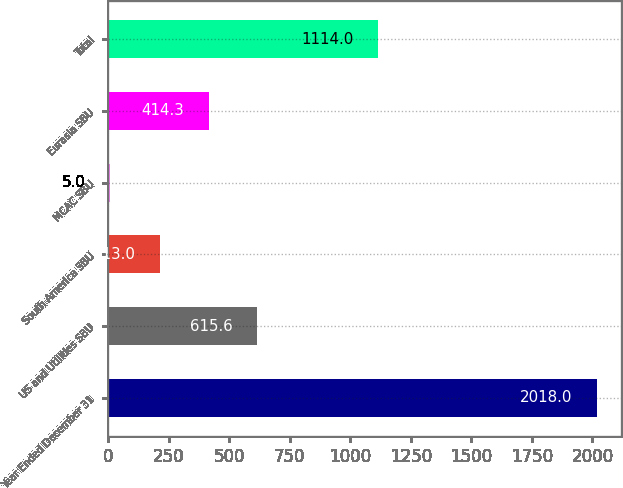Convert chart to OTSL. <chart><loc_0><loc_0><loc_500><loc_500><bar_chart><fcel>Year Ended December 31<fcel>US and Utilities SBU<fcel>South America SBU<fcel>MCAC SBU<fcel>Eurasia SBU<fcel>Total<nl><fcel>2018<fcel>615.6<fcel>213<fcel>5<fcel>414.3<fcel>1114<nl></chart> 